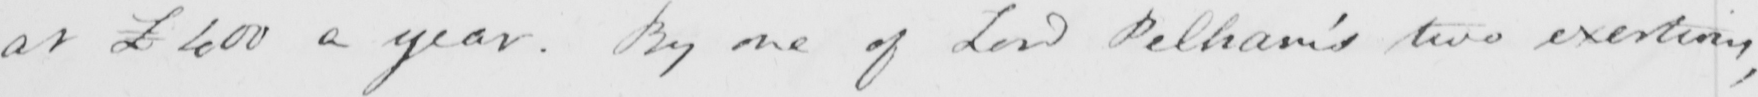What does this handwritten line say? at £400 a year . By one of Lord Pelham ' s two exertions , 